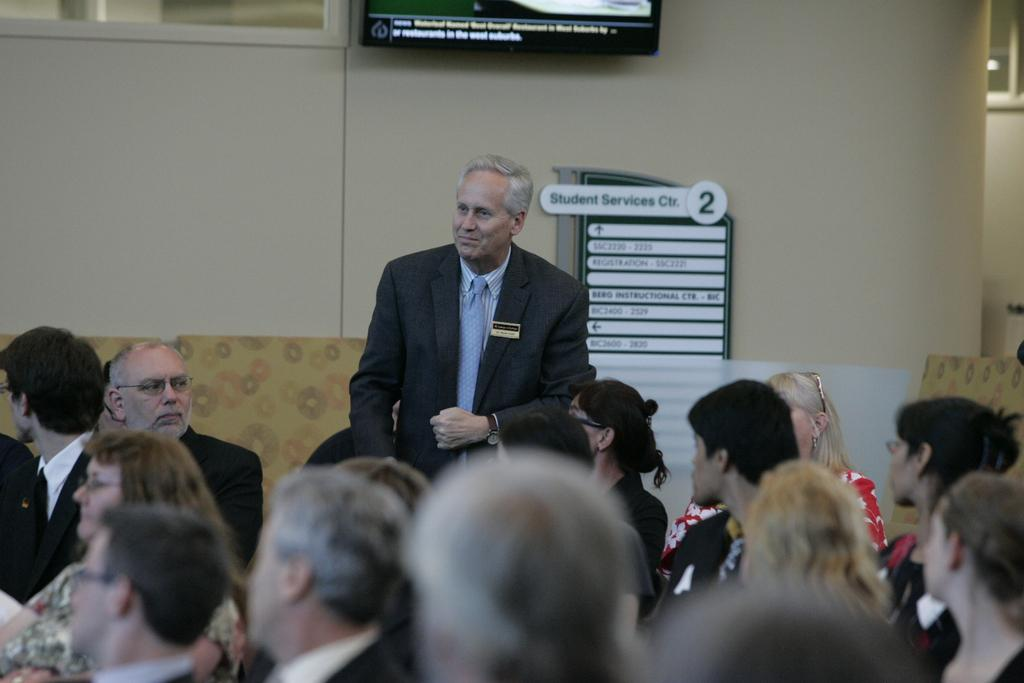What is the main subject of the image? The main subject of the image is a group of people. Can you describe the appearance of one of the individuals in the group? Yes, a man is wearing a blazer and a tie. What is the man doing in the image? The man is standing and smiling. What can be seen in the background of the image? There is a television, name boards, and a wall in the background of the image. What type of winter clothing is the man wearing in the image? The man is not wearing any winter clothing in the image; he is wearing a blazer and a tie. Can you see a tooth in the image? There is no tooth present in the image. 